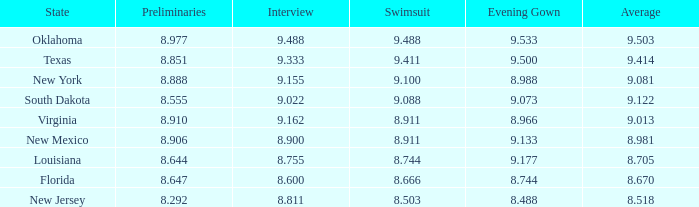 what's the swimsuit where average is 8.670 8.666. 